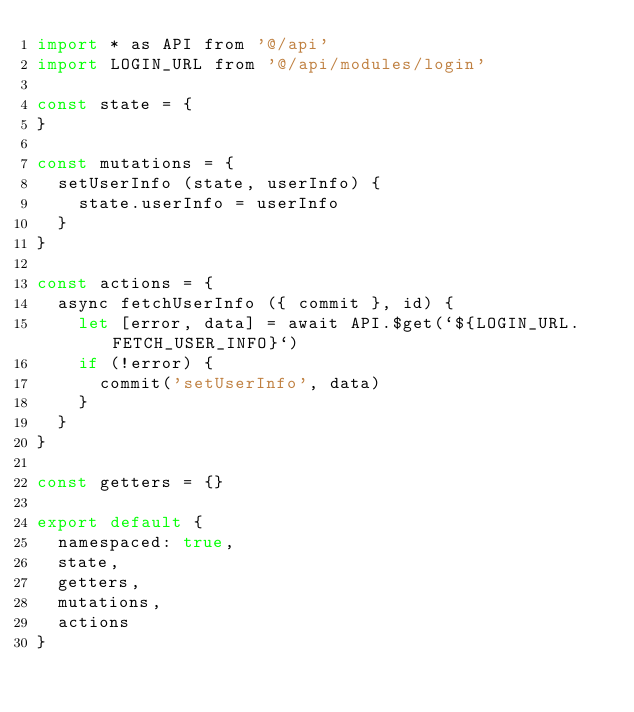Convert code to text. <code><loc_0><loc_0><loc_500><loc_500><_JavaScript_>import * as API from '@/api'
import LOGIN_URL from '@/api/modules/login'

const state = {
}

const mutations = {
  setUserInfo (state, userInfo) {
    state.userInfo = userInfo
  }
}

const actions = {
  async fetchUserInfo ({ commit }, id) {
    let [error, data] = await API.$get(`${LOGIN_URL.FETCH_USER_INFO}`)
    if (!error) {
      commit('setUserInfo', data)
    }
  }
}

const getters = {}

export default {
  namespaced: true,
  state,
  getters,
  mutations,
  actions
}
</code> 